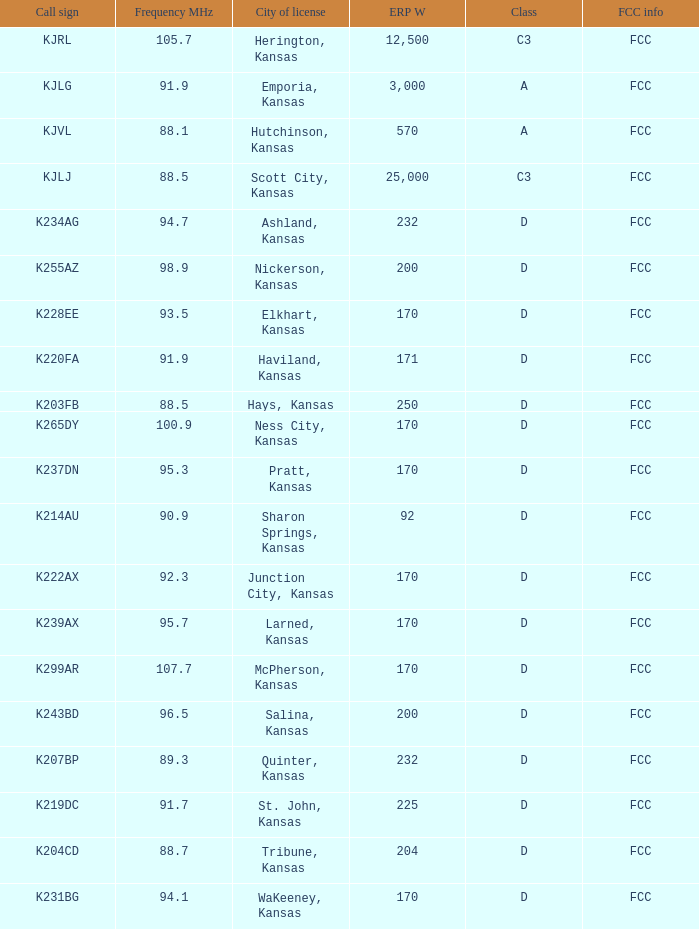Can you parse all the data within this table? {'header': ['Call sign', 'Frequency MHz', 'City of license', 'ERP W', 'Class', 'FCC info'], 'rows': [['KJRL', '105.7', 'Herington, Kansas', '12,500', 'C3', 'FCC'], ['KJLG', '91.9', 'Emporia, Kansas', '3,000', 'A', 'FCC'], ['KJVL', '88.1', 'Hutchinson, Kansas', '570', 'A', 'FCC'], ['KJLJ', '88.5', 'Scott City, Kansas', '25,000', 'C3', 'FCC'], ['K234AG', '94.7', 'Ashland, Kansas', '232', 'D', 'FCC'], ['K255AZ', '98.9', 'Nickerson, Kansas', '200', 'D', 'FCC'], ['K228EE', '93.5', 'Elkhart, Kansas', '170', 'D', 'FCC'], ['K220FA', '91.9', 'Haviland, Kansas', '171', 'D', 'FCC'], ['K203FB', '88.5', 'Hays, Kansas', '250', 'D', 'FCC'], ['K265DY', '100.9', 'Ness City, Kansas', '170', 'D', 'FCC'], ['K237DN', '95.3', 'Pratt, Kansas', '170', 'D', 'FCC'], ['K214AU', '90.9', 'Sharon Springs, Kansas', '92', 'D', 'FCC'], ['K222AX', '92.3', 'Junction City, Kansas', '170', 'D', 'FCC'], ['K239AX', '95.7', 'Larned, Kansas', '170', 'D', 'FCC'], ['K299AR', '107.7', 'McPherson, Kansas', '170', 'D', 'FCC'], ['K243BD', '96.5', 'Salina, Kansas', '200', 'D', 'FCC'], ['K207BP', '89.3', 'Quinter, Kansas', '232', 'D', 'FCC'], ['K219DC', '91.7', 'St. John, Kansas', '225', 'D', 'FCC'], ['K204CD', '88.7', 'Tribune, Kansas', '204', 'D', 'FCC'], ['K231BG', '94.1', 'WaKeeney, Kansas', '170', 'D', 'FCC']]} Class of d, and a Frequency MHz smaller than 107.7, and a ERP W smaller than 232 has what call sign? K255AZ, K228EE, K220FA, K265DY, K237DN, K214AU, K222AX, K239AX, K243BD, K219DC, K204CD, K231BG. 